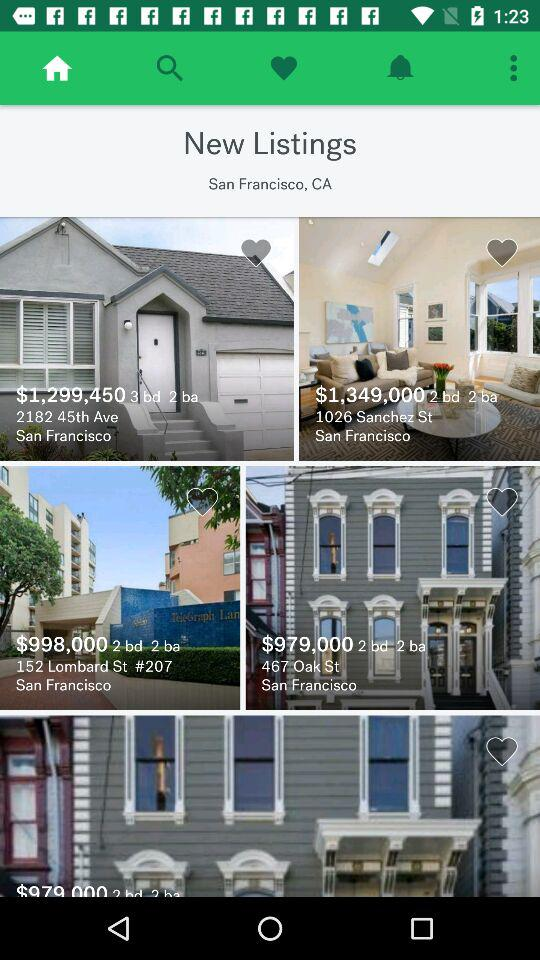What is the price of the house whose address is 1026 Sanchez St.? The price is $1,349,000. 